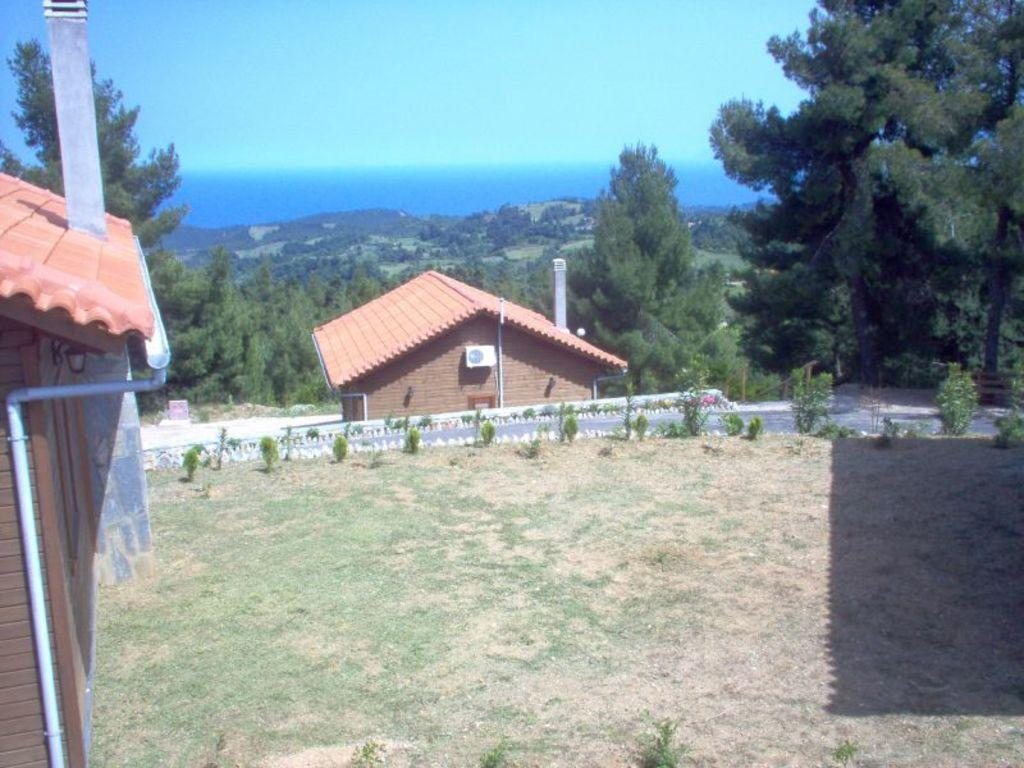What is the main structure in the middle of the image? There is a house in the middle of the image. What else can be seen in the image besides the house? There is a road and trees visible in the image. What is visible at the top of the image? The sky is visible at the top of the image. Can you see a crown on the trees in the image? There is no crown present on the trees in the image. How many passengers are visible in the image? There are no passengers visible in the image. 